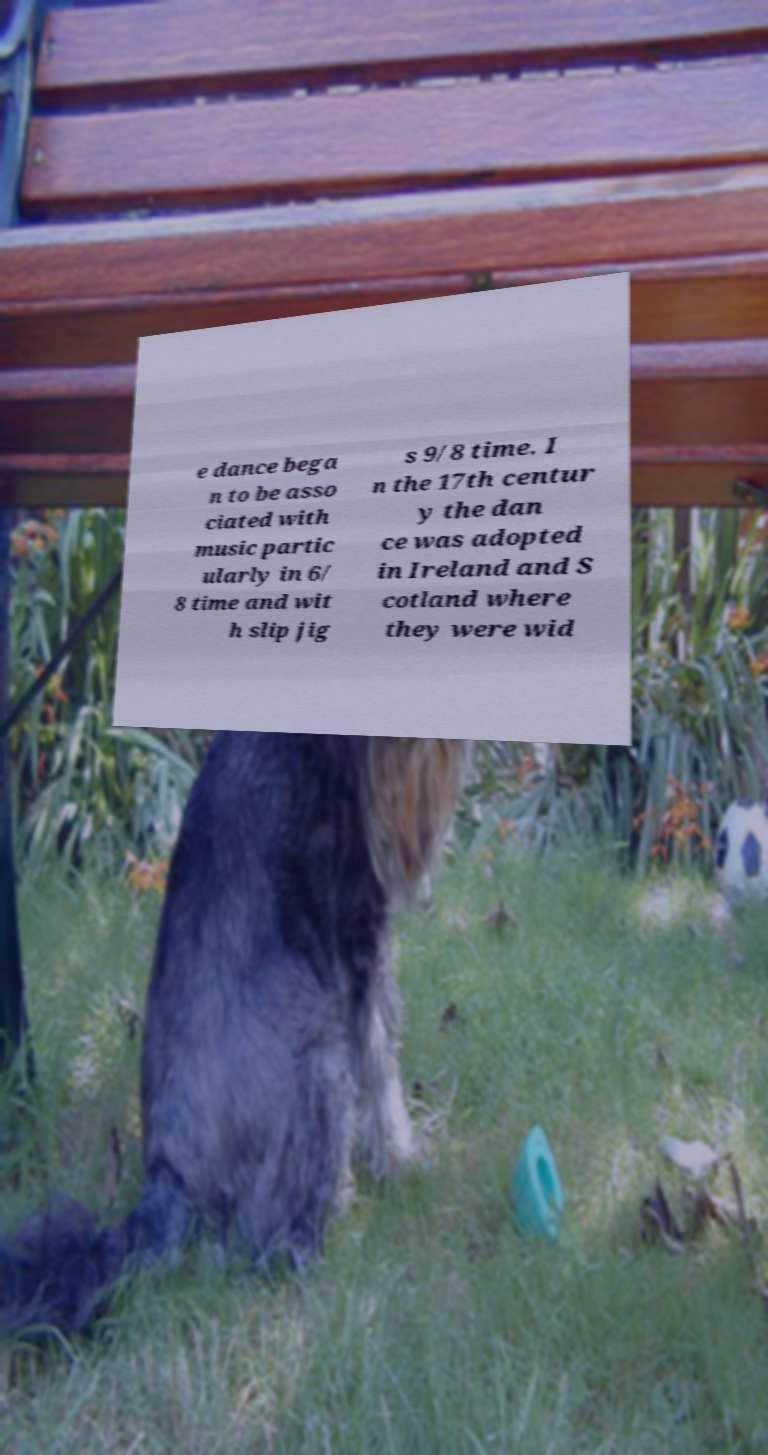Could you assist in decoding the text presented in this image and type it out clearly? e dance bega n to be asso ciated with music partic ularly in 6/ 8 time and wit h slip jig s 9/8 time. I n the 17th centur y the dan ce was adopted in Ireland and S cotland where they were wid 